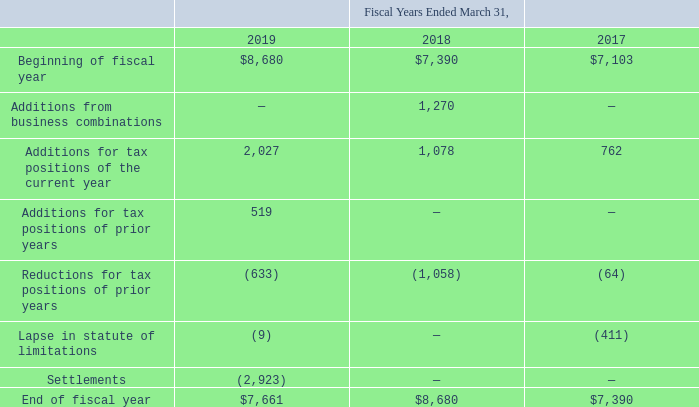At March 31, 2019, the Company had $7.7 million of unrecognized tax benefits. A reconciliation of gross unrecognized tax benefits (excluding interest and penalties) is as follows (amounts in thousands):
At March 31, 2019, $1.9 million of the $7.7 million of unrecognized income tax benefits would affect the Company’s effective income tax rate, if recognized. It is reasonably possible that the total unrecognized tax benefit could decrease by $1.0 million in fiscal year 2020 if the advanced pricing arrangement for one of the Company’s foreign subsidiaries is agreed to by the foreign tax authority and an ongoing audit in one of the Company’s foreign jurisdictions is settled.
The Company files income tax returns in the U.S. and multiple foreign jurisdictions, including various state and local jurisdictions. The U.S. Internal Revenue Service concluded its examinations of the Company’s U.S. federal tax returns for all tax years through 2003. Because of net operating losses, the Company’s U.S. federal returns for 2003 and later years will remain subject to examination until the losses are utilized. The Company is subject to income tax examinations in various foreign and U.S. state jurisdictions for the years 2014 and forward. The Company records potential interest and penalty expenses related to unrecognized income tax benefits within its global operations in income tax expense. The Company had $0.5 million and $0.9 million of accrued interest and penalties respectively at March 31, 2019 and 2018, which are included as a component of income tax expense. To the extent interest and penalties are not assessed with respect to uncertain tax positions, amounts accrued will be reduced and reflected as a reduction of the overall income tax provision.
Which years does the table provide information for the gross unrecognized tax benefits for the company? 2019, 2018, 2017. What was the amount of gross unrecognized tax benefits at the beginning of fiscal year in 2019?
Answer scale should be: thousand. 8,680. What was the Lapse in statute of limitations in 2017?
Answer scale should be: thousand. (411). What was the change in the Additions for tax positions of the current year between 2018 and 2019?
Answer scale should be: thousand. 2,027-1,078
Answer: 949. What was the change in the balance at the Beginning of fiscal year between 2017 and 2019?
Answer scale should be: thousand. 8,680-7,103
Answer: 1577. What was the percentage change in the end of fiscal year balance between 2017 and 2018?
Answer scale should be: percent. (8,680-7,390)/7,390
Answer: 17.46. 